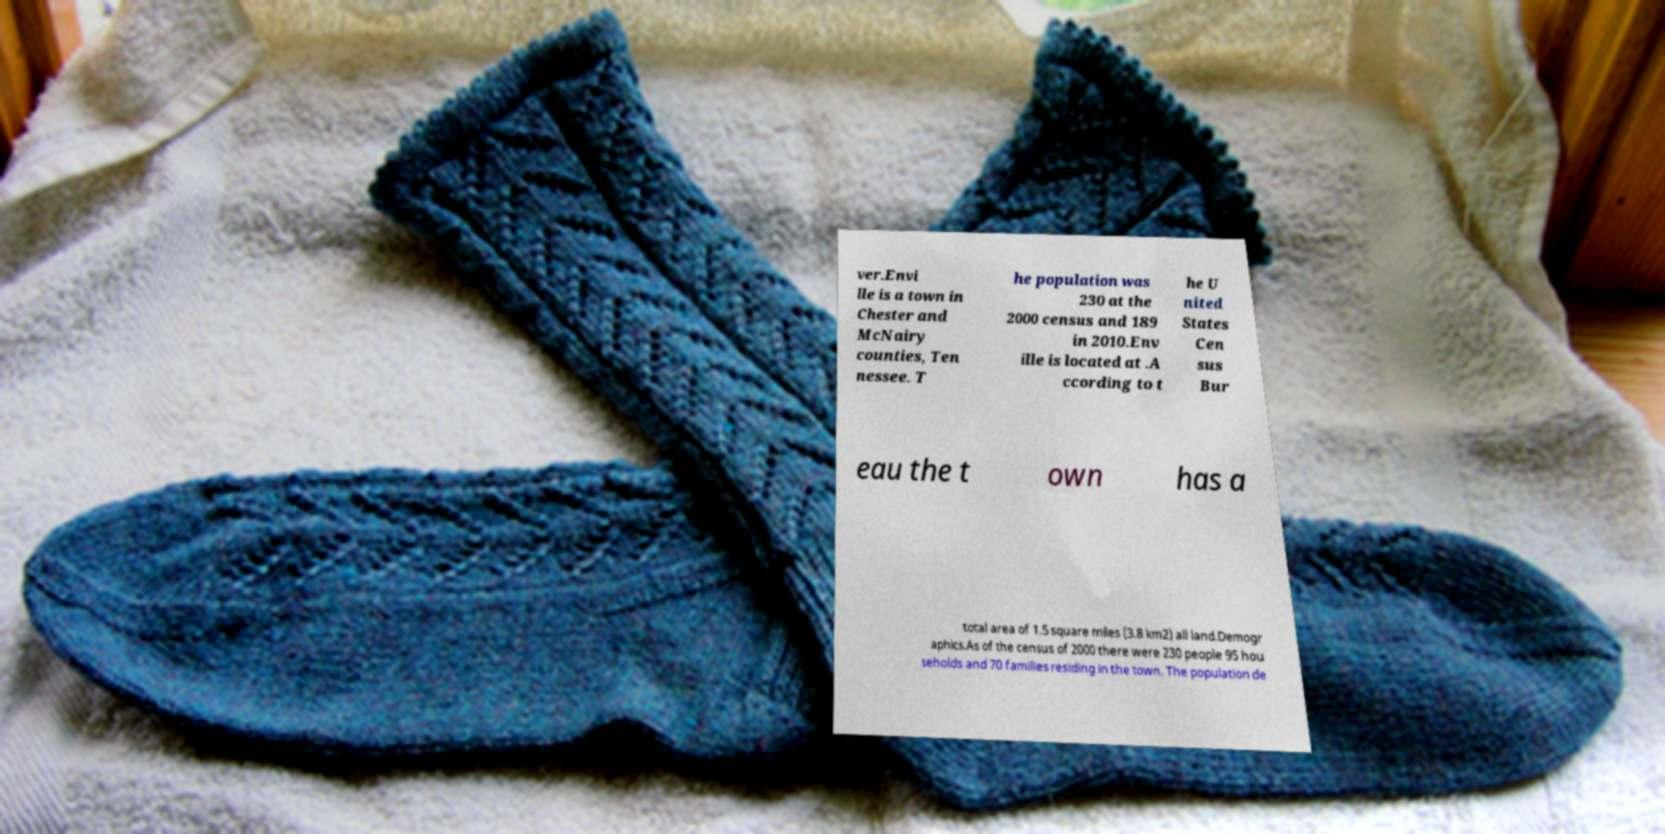I need the written content from this picture converted into text. Can you do that? ver.Envi lle is a town in Chester and McNairy counties, Ten nessee. T he population was 230 at the 2000 census and 189 in 2010.Env ille is located at .A ccording to t he U nited States Cen sus Bur eau the t own has a total area of 1.5 square miles (3.8 km2) all land.Demogr aphics.As of the census of 2000 there were 230 people 95 hou seholds and 70 families residing in the town. The population de 